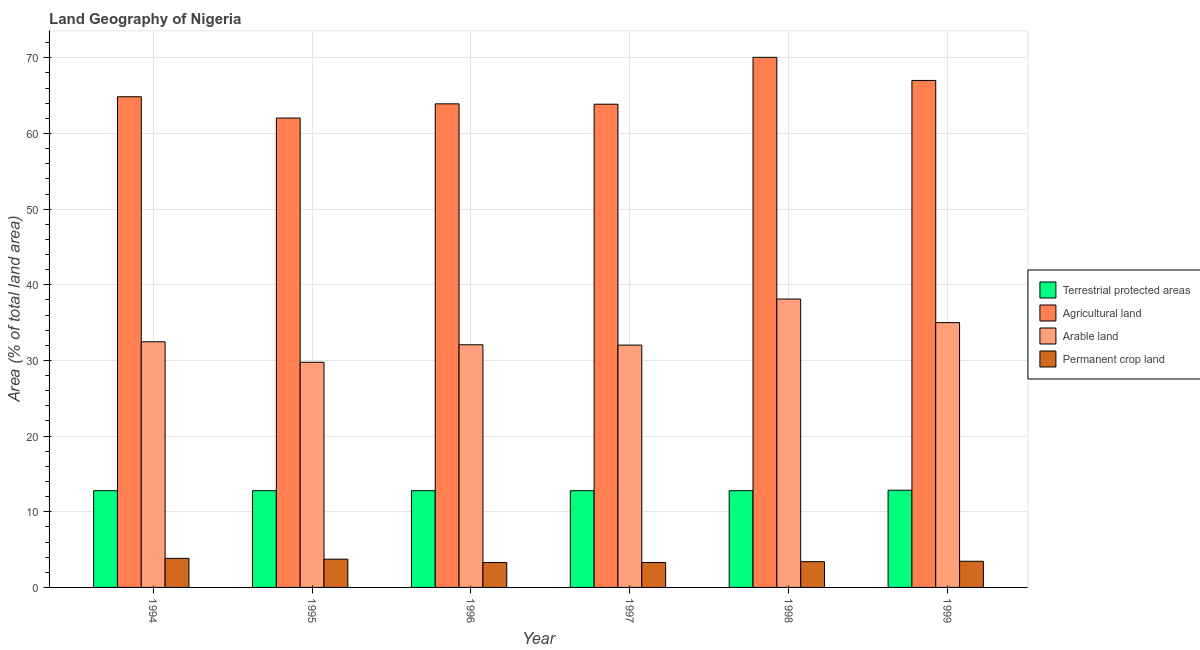How many different coloured bars are there?
Offer a very short reply. 4. Are the number of bars per tick equal to the number of legend labels?
Offer a terse response. Yes. How many bars are there on the 2nd tick from the left?
Ensure brevity in your answer.  4. What is the label of the 4th group of bars from the left?
Your answer should be compact. 1997. What is the percentage of area under arable land in 1995?
Your answer should be very brief. 29.76. Across all years, what is the maximum percentage of area under permanent crop land?
Keep it short and to the point. 3.84. Across all years, what is the minimum percentage of area under arable land?
Keep it short and to the point. 29.76. In which year was the percentage of land under terrestrial protection maximum?
Provide a short and direct response. 1999. What is the total percentage of land under terrestrial protection in the graph?
Give a very brief answer. 76.76. What is the difference between the percentage of area under permanent crop land in 1994 and that in 1996?
Your response must be concise. 0.55. What is the difference between the percentage of area under arable land in 1994 and the percentage of area under agricultural land in 1999?
Your answer should be very brief. -2.54. What is the average percentage of area under arable land per year?
Your response must be concise. 33.24. In how many years, is the percentage of area under permanent crop land greater than 62 %?
Offer a very short reply. 0. What is the ratio of the percentage of land under terrestrial protection in 1995 to that in 1998?
Your response must be concise. 1. Is the percentage of land under terrestrial protection in 1995 less than that in 1999?
Provide a short and direct response. Yes. Is the difference between the percentage of land under terrestrial protection in 1995 and 1997 greater than the difference between the percentage of area under agricultural land in 1995 and 1997?
Offer a terse response. No. What is the difference between the highest and the second highest percentage of area under agricultural land?
Make the answer very short. 3.06. What is the difference between the highest and the lowest percentage of area under permanent crop land?
Give a very brief answer. 0.55. Is the sum of the percentage of area under permanent crop land in 1998 and 1999 greater than the maximum percentage of land under terrestrial protection across all years?
Give a very brief answer. Yes. What does the 2nd bar from the left in 1997 represents?
Offer a terse response. Agricultural land. What does the 2nd bar from the right in 1997 represents?
Give a very brief answer. Arable land. Is it the case that in every year, the sum of the percentage of land under terrestrial protection and percentage of area under agricultural land is greater than the percentage of area under arable land?
Your answer should be compact. Yes. What is the difference between two consecutive major ticks on the Y-axis?
Provide a short and direct response. 10. Does the graph contain grids?
Keep it short and to the point. Yes. How many legend labels are there?
Offer a terse response. 4. How are the legend labels stacked?
Make the answer very short. Vertical. What is the title of the graph?
Your answer should be compact. Land Geography of Nigeria. What is the label or title of the X-axis?
Give a very brief answer. Year. What is the label or title of the Y-axis?
Your answer should be very brief. Area (% of total land area). What is the Area (% of total land area) in Terrestrial protected areas in 1994?
Make the answer very short. 12.78. What is the Area (% of total land area) in Agricultural land in 1994?
Offer a terse response. 64.86. What is the Area (% of total land area) of Arable land in 1994?
Provide a succinct answer. 32.47. What is the Area (% of total land area) of Permanent crop land in 1994?
Offer a terse response. 3.84. What is the Area (% of total land area) in Terrestrial protected areas in 1995?
Make the answer very short. 12.78. What is the Area (% of total land area) of Agricultural land in 1995?
Give a very brief answer. 62.04. What is the Area (% of total land area) in Arable land in 1995?
Make the answer very short. 29.76. What is the Area (% of total land area) of Permanent crop land in 1995?
Your response must be concise. 3.73. What is the Area (% of total land area) of Terrestrial protected areas in 1996?
Provide a succinct answer. 12.78. What is the Area (% of total land area) in Agricultural land in 1996?
Make the answer very short. 63.92. What is the Area (% of total land area) of Arable land in 1996?
Your answer should be compact. 32.07. What is the Area (% of total land area) in Permanent crop land in 1996?
Make the answer very short. 3.29. What is the Area (% of total land area) in Terrestrial protected areas in 1997?
Offer a terse response. 12.78. What is the Area (% of total land area) in Agricultural land in 1997?
Ensure brevity in your answer.  63.87. What is the Area (% of total land area) of Arable land in 1997?
Your response must be concise. 32.03. What is the Area (% of total land area) in Permanent crop land in 1997?
Make the answer very short. 3.29. What is the Area (% of total land area) of Terrestrial protected areas in 1998?
Your answer should be very brief. 12.78. What is the Area (% of total land area) of Agricultural land in 1998?
Your answer should be very brief. 70.07. What is the Area (% of total land area) of Arable land in 1998?
Provide a short and direct response. 38.12. What is the Area (% of total land area) of Permanent crop land in 1998?
Offer a terse response. 3.4. What is the Area (% of total land area) of Terrestrial protected areas in 1999?
Ensure brevity in your answer.  12.84. What is the Area (% of total land area) of Agricultural land in 1999?
Offer a terse response. 67.01. What is the Area (% of total land area) in Arable land in 1999?
Make the answer very short. 35. What is the Area (% of total land area) of Permanent crop land in 1999?
Keep it short and to the point. 3.46. Across all years, what is the maximum Area (% of total land area) of Terrestrial protected areas?
Give a very brief answer. 12.84. Across all years, what is the maximum Area (% of total land area) in Agricultural land?
Provide a succinct answer. 70.07. Across all years, what is the maximum Area (% of total land area) in Arable land?
Offer a terse response. 38.12. Across all years, what is the maximum Area (% of total land area) in Permanent crop land?
Make the answer very short. 3.84. Across all years, what is the minimum Area (% of total land area) of Terrestrial protected areas?
Give a very brief answer. 12.78. Across all years, what is the minimum Area (% of total land area) in Agricultural land?
Provide a short and direct response. 62.04. Across all years, what is the minimum Area (% of total land area) in Arable land?
Your response must be concise. 29.76. Across all years, what is the minimum Area (% of total land area) in Permanent crop land?
Offer a terse response. 3.29. What is the total Area (% of total land area) of Terrestrial protected areas in the graph?
Ensure brevity in your answer.  76.76. What is the total Area (% of total land area) in Agricultural land in the graph?
Provide a short and direct response. 391.76. What is the total Area (% of total land area) in Arable land in the graph?
Your answer should be very brief. 199.45. What is the total Area (% of total land area) of Permanent crop land in the graph?
Your answer should be very brief. 21.03. What is the difference between the Area (% of total land area) of Terrestrial protected areas in 1994 and that in 1995?
Give a very brief answer. 0. What is the difference between the Area (% of total land area) of Agricultural land in 1994 and that in 1995?
Your response must be concise. 2.82. What is the difference between the Area (% of total land area) in Arable land in 1994 and that in 1995?
Your answer should be compact. 2.71. What is the difference between the Area (% of total land area) in Permanent crop land in 1994 and that in 1995?
Provide a short and direct response. 0.11. What is the difference between the Area (% of total land area) of Terrestrial protected areas in 1994 and that in 1996?
Offer a terse response. 0. What is the difference between the Area (% of total land area) in Arable land in 1994 and that in 1996?
Ensure brevity in your answer.  0.39. What is the difference between the Area (% of total land area) in Permanent crop land in 1994 and that in 1996?
Give a very brief answer. 0.55. What is the difference between the Area (% of total land area) of Agricultural land in 1994 and that in 1997?
Make the answer very short. 0.99. What is the difference between the Area (% of total land area) in Arable land in 1994 and that in 1997?
Give a very brief answer. 0.44. What is the difference between the Area (% of total land area) of Permanent crop land in 1994 and that in 1997?
Ensure brevity in your answer.  0.55. What is the difference between the Area (% of total land area) of Terrestrial protected areas in 1994 and that in 1998?
Your answer should be very brief. 0. What is the difference between the Area (% of total land area) in Agricultural land in 1994 and that in 1998?
Ensure brevity in your answer.  -5.21. What is the difference between the Area (% of total land area) in Arable land in 1994 and that in 1998?
Your answer should be very brief. -5.65. What is the difference between the Area (% of total land area) of Permanent crop land in 1994 and that in 1998?
Keep it short and to the point. 0.44. What is the difference between the Area (% of total land area) of Terrestrial protected areas in 1994 and that in 1999?
Your answer should be very brief. -0.06. What is the difference between the Area (% of total land area) in Agricultural land in 1994 and that in 1999?
Make the answer very short. -2.15. What is the difference between the Area (% of total land area) in Arable land in 1994 and that in 1999?
Keep it short and to the point. -2.54. What is the difference between the Area (% of total land area) of Permanent crop land in 1994 and that in 1999?
Keep it short and to the point. 0.38. What is the difference between the Area (% of total land area) of Agricultural land in 1995 and that in 1996?
Your answer should be very brief. -1.87. What is the difference between the Area (% of total land area) in Arable land in 1995 and that in 1996?
Provide a succinct answer. -2.31. What is the difference between the Area (% of total land area) in Permanent crop land in 1995 and that in 1996?
Provide a short and direct response. 0.44. What is the difference between the Area (% of total land area) of Agricultural land in 1995 and that in 1997?
Your answer should be very brief. -1.83. What is the difference between the Area (% of total land area) of Arable land in 1995 and that in 1997?
Give a very brief answer. -2.27. What is the difference between the Area (% of total land area) of Permanent crop land in 1995 and that in 1997?
Offer a very short reply. 0.44. What is the difference between the Area (% of total land area) of Agricultural land in 1995 and that in 1998?
Offer a very short reply. -8.02. What is the difference between the Area (% of total land area) in Arable land in 1995 and that in 1998?
Make the answer very short. -8.35. What is the difference between the Area (% of total land area) in Permanent crop land in 1995 and that in 1998?
Give a very brief answer. 0.33. What is the difference between the Area (% of total land area) of Terrestrial protected areas in 1995 and that in 1999?
Provide a succinct answer. -0.06. What is the difference between the Area (% of total land area) of Agricultural land in 1995 and that in 1999?
Give a very brief answer. -4.97. What is the difference between the Area (% of total land area) in Arable land in 1995 and that in 1999?
Give a very brief answer. -5.24. What is the difference between the Area (% of total land area) of Permanent crop land in 1995 and that in 1999?
Offer a very short reply. 0.27. What is the difference between the Area (% of total land area) of Terrestrial protected areas in 1996 and that in 1997?
Offer a terse response. 0. What is the difference between the Area (% of total land area) in Agricultural land in 1996 and that in 1997?
Keep it short and to the point. 0.04. What is the difference between the Area (% of total land area) in Arable land in 1996 and that in 1997?
Make the answer very short. 0.04. What is the difference between the Area (% of total land area) of Terrestrial protected areas in 1996 and that in 1998?
Give a very brief answer. 0. What is the difference between the Area (% of total land area) of Agricultural land in 1996 and that in 1998?
Your response must be concise. -6.15. What is the difference between the Area (% of total land area) in Arable land in 1996 and that in 1998?
Keep it short and to the point. -6.04. What is the difference between the Area (% of total land area) of Permanent crop land in 1996 and that in 1998?
Provide a succinct answer. -0.11. What is the difference between the Area (% of total land area) of Terrestrial protected areas in 1996 and that in 1999?
Give a very brief answer. -0.06. What is the difference between the Area (% of total land area) in Agricultural land in 1996 and that in 1999?
Make the answer very short. -3.09. What is the difference between the Area (% of total land area) of Arable land in 1996 and that in 1999?
Give a very brief answer. -2.93. What is the difference between the Area (% of total land area) of Permanent crop land in 1996 and that in 1999?
Your response must be concise. -0.16. What is the difference between the Area (% of total land area) of Agricultural land in 1997 and that in 1998?
Offer a very short reply. -6.19. What is the difference between the Area (% of total land area) of Arable land in 1997 and that in 1998?
Offer a terse response. -6.08. What is the difference between the Area (% of total land area) in Permanent crop land in 1997 and that in 1998?
Make the answer very short. -0.11. What is the difference between the Area (% of total land area) in Terrestrial protected areas in 1997 and that in 1999?
Keep it short and to the point. -0.06. What is the difference between the Area (% of total land area) of Agricultural land in 1997 and that in 1999?
Keep it short and to the point. -3.14. What is the difference between the Area (% of total land area) in Arable land in 1997 and that in 1999?
Your answer should be compact. -2.97. What is the difference between the Area (% of total land area) of Permanent crop land in 1997 and that in 1999?
Make the answer very short. -0.16. What is the difference between the Area (% of total land area) in Terrestrial protected areas in 1998 and that in 1999?
Provide a short and direct response. -0.06. What is the difference between the Area (% of total land area) of Agricultural land in 1998 and that in 1999?
Your answer should be very brief. 3.06. What is the difference between the Area (% of total land area) in Arable land in 1998 and that in 1999?
Provide a succinct answer. 3.11. What is the difference between the Area (% of total land area) of Permanent crop land in 1998 and that in 1999?
Your response must be concise. -0.05. What is the difference between the Area (% of total land area) in Terrestrial protected areas in 1994 and the Area (% of total land area) in Agricultural land in 1995?
Your answer should be compact. -49.26. What is the difference between the Area (% of total land area) in Terrestrial protected areas in 1994 and the Area (% of total land area) in Arable land in 1995?
Your answer should be very brief. -16.98. What is the difference between the Area (% of total land area) of Terrestrial protected areas in 1994 and the Area (% of total land area) of Permanent crop land in 1995?
Keep it short and to the point. 9.05. What is the difference between the Area (% of total land area) in Agricultural land in 1994 and the Area (% of total land area) in Arable land in 1995?
Provide a succinct answer. 35.1. What is the difference between the Area (% of total land area) of Agricultural land in 1994 and the Area (% of total land area) of Permanent crop land in 1995?
Offer a terse response. 61.12. What is the difference between the Area (% of total land area) in Arable land in 1994 and the Area (% of total land area) in Permanent crop land in 1995?
Provide a short and direct response. 28.73. What is the difference between the Area (% of total land area) in Terrestrial protected areas in 1994 and the Area (% of total land area) in Agricultural land in 1996?
Give a very brief answer. -51.13. What is the difference between the Area (% of total land area) in Terrestrial protected areas in 1994 and the Area (% of total land area) in Arable land in 1996?
Give a very brief answer. -19.29. What is the difference between the Area (% of total land area) in Terrestrial protected areas in 1994 and the Area (% of total land area) in Permanent crop land in 1996?
Offer a terse response. 9.49. What is the difference between the Area (% of total land area) of Agricultural land in 1994 and the Area (% of total land area) of Arable land in 1996?
Offer a very short reply. 32.78. What is the difference between the Area (% of total land area) in Agricultural land in 1994 and the Area (% of total land area) in Permanent crop land in 1996?
Offer a very short reply. 61.56. What is the difference between the Area (% of total land area) of Arable land in 1994 and the Area (% of total land area) of Permanent crop land in 1996?
Offer a terse response. 29.17. What is the difference between the Area (% of total land area) of Terrestrial protected areas in 1994 and the Area (% of total land area) of Agricultural land in 1997?
Provide a succinct answer. -51.09. What is the difference between the Area (% of total land area) in Terrestrial protected areas in 1994 and the Area (% of total land area) in Arable land in 1997?
Offer a very short reply. -19.25. What is the difference between the Area (% of total land area) of Terrestrial protected areas in 1994 and the Area (% of total land area) of Permanent crop land in 1997?
Your answer should be very brief. 9.49. What is the difference between the Area (% of total land area) of Agricultural land in 1994 and the Area (% of total land area) of Arable land in 1997?
Keep it short and to the point. 32.83. What is the difference between the Area (% of total land area) in Agricultural land in 1994 and the Area (% of total land area) in Permanent crop land in 1997?
Give a very brief answer. 61.56. What is the difference between the Area (% of total land area) of Arable land in 1994 and the Area (% of total land area) of Permanent crop land in 1997?
Provide a succinct answer. 29.17. What is the difference between the Area (% of total land area) of Terrestrial protected areas in 1994 and the Area (% of total land area) of Agricultural land in 1998?
Offer a very short reply. -57.28. What is the difference between the Area (% of total land area) in Terrestrial protected areas in 1994 and the Area (% of total land area) in Arable land in 1998?
Keep it short and to the point. -25.33. What is the difference between the Area (% of total land area) of Terrestrial protected areas in 1994 and the Area (% of total land area) of Permanent crop land in 1998?
Make the answer very short. 9.38. What is the difference between the Area (% of total land area) in Agricultural land in 1994 and the Area (% of total land area) in Arable land in 1998?
Ensure brevity in your answer.  26.74. What is the difference between the Area (% of total land area) in Agricultural land in 1994 and the Area (% of total land area) in Permanent crop land in 1998?
Your answer should be very brief. 61.45. What is the difference between the Area (% of total land area) in Arable land in 1994 and the Area (% of total land area) in Permanent crop land in 1998?
Provide a succinct answer. 29.06. What is the difference between the Area (% of total land area) of Terrestrial protected areas in 1994 and the Area (% of total land area) of Agricultural land in 1999?
Offer a very short reply. -54.23. What is the difference between the Area (% of total land area) in Terrestrial protected areas in 1994 and the Area (% of total land area) in Arable land in 1999?
Provide a short and direct response. -22.22. What is the difference between the Area (% of total land area) in Terrestrial protected areas in 1994 and the Area (% of total land area) in Permanent crop land in 1999?
Offer a terse response. 9.32. What is the difference between the Area (% of total land area) of Agricultural land in 1994 and the Area (% of total land area) of Arable land in 1999?
Offer a terse response. 29.85. What is the difference between the Area (% of total land area) of Agricultural land in 1994 and the Area (% of total land area) of Permanent crop land in 1999?
Offer a terse response. 61.4. What is the difference between the Area (% of total land area) in Arable land in 1994 and the Area (% of total land area) in Permanent crop land in 1999?
Provide a short and direct response. 29.01. What is the difference between the Area (% of total land area) of Terrestrial protected areas in 1995 and the Area (% of total land area) of Agricultural land in 1996?
Make the answer very short. -51.13. What is the difference between the Area (% of total land area) of Terrestrial protected areas in 1995 and the Area (% of total land area) of Arable land in 1996?
Your answer should be compact. -19.29. What is the difference between the Area (% of total land area) in Terrestrial protected areas in 1995 and the Area (% of total land area) in Permanent crop land in 1996?
Provide a short and direct response. 9.49. What is the difference between the Area (% of total land area) of Agricultural land in 1995 and the Area (% of total land area) of Arable land in 1996?
Give a very brief answer. 29.97. What is the difference between the Area (% of total land area) in Agricultural land in 1995 and the Area (% of total land area) in Permanent crop land in 1996?
Offer a very short reply. 58.75. What is the difference between the Area (% of total land area) in Arable land in 1995 and the Area (% of total land area) in Permanent crop land in 1996?
Offer a very short reply. 26.47. What is the difference between the Area (% of total land area) of Terrestrial protected areas in 1995 and the Area (% of total land area) of Agricultural land in 1997?
Your response must be concise. -51.09. What is the difference between the Area (% of total land area) of Terrestrial protected areas in 1995 and the Area (% of total land area) of Arable land in 1997?
Offer a very short reply. -19.25. What is the difference between the Area (% of total land area) in Terrestrial protected areas in 1995 and the Area (% of total land area) in Permanent crop land in 1997?
Offer a very short reply. 9.49. What is the difference between the Area (% of total land area) in Agricultural land in 1995 and the Area (% of total land area) in Arable land in 1997?
Give a very brief answer. 30.01. What is the difference between the Area (% of total land area) of Agricultural land in 1995 and the Area (% of total land area) of Permanent crop land in 1997?
Your answer should be very brief. 58.75. What is the difference between the Area (% of total land area) in Arable land in 1995 and the Area (% of total land area) in Permanent crop land in 1997?
Give a very brief answer. 26.47. What is the difference between the Area (% of total land area) in Terrestrial protected areas in 1995 and the Area (% of total land area) in Agricultural land in 1998?
Give a very brief answer. -57.28. What is the difference between the Area (% of total land area) of Terrestrial protected areas in 1995 and the Area (% of total land area) of Arable land in 1998?
Give a very brief answer. -25.33. What is the difference between the Area (% of total land area) in Terrestrial protected areas in 1995 and the Area (% of total land area) in Permanent crop land in 1998?
Ensure brevity in your answer.  9.38. What is the difference between the Area (% of total land area) of Agricultural land in 1995 and the Area (% of total land area) of Arable land in 1998?
Give a very brief answer. 23.93. What is the difference between the Area (% of total land area) of Agricultural land in 1995 and the Area (% of total land area) of Permanent crop land in 1998?
Provide a short and direct response. 58.64. What is the difference between the Area (% of total land area) in Arable land in 1995 and the Area (% of total land area) in Permanent crop land in 1998?
Offer a terse response. 26.36. What is the difference between the Area (% of total land area) in Terrestrial protected areas in 1995 and the Area (% of total land area) in Agricultural land in 1999?
Ensure brevity in your answer.  -54.23. What is the difference between the Area (% of total land area) in Terrestrial protected areas in 1995 and the Area (% of total land area) in Arable land in 1999?
Offer a very short reply. -22.22. What is the difference between the Area (% of total land area) in Terrestrial protected areas in 1995 and the Area (% of total land area) in Permanent crop land in 1999?
Make the answer very short. 9.32. What is the difference between the Area (% of total land area) in Agricultural land in 1995 and the Area (% of total land area) in Arable land in 1999?
Your answer should be compact. 27.04. What is the difference between the Area (% of total land area) of Agricultural land in 1995 and the Area (% of total land area) of Permanent crop land in 1999?
Your answer should be compact. 58.58. What is the difference between the Area (% of total land area) of Arable land in 1995 and the Area (% of total land area) of Permanent crop land in 1999?
Your answer should be very brief. 26.3. What is the difference between the Area (% of total land area) in Terrestrial protected areas in 1996 and the Area (% of total land area) in Agricultural land in 1997?
Provide a short and direct response. -51.09. What is the difference between the Area (% of total land area) of Terrestrial protected areas in 1996 and the Area (% of total land area) of Arable land in 1997?
Your response must be concise. -19.25. What is the difference between the Area (% of total land area) in Terrestrial protected areas in 1996 and the Area (% of total land area) in Permanent crop land in 1997?
Provide a succinct answer. 9.49. What is the difference between the Area (% of total land area) in Agricultural land in 1996 and the Area (% of total land area) in Arable land in 1997?
Your response must be concise. 31.89. What is the difference between the Area (% of total land area) in Agricultural land in 1996 and the Area (% of total land area) in Permanent crop land in 1997?
Make the answer very short. 60.62. What is the difference between the Area (% of total land area) of Arable land in 1996 and the Area (% of total land area) of Permanent crop land in 1997?
Give a very brief answer. 28.78. What is the difference between the Area (% of total land area) of Terrestrial protected areas in 1996 and the Area (% of total land area) of Agricultural land in 1998?
Provide a short and direct response. -57.28. What is the difference between the Area (% of total land area) in Terrestrial protected areas in 1996 and the Area (% of total land area) in Arable land in 1998?
Keep it short and to the point. -25.33. What is the difference between the Area (% of total land area) in Terrestrial protected areas in 1996 and the Area (% of total land area) in Permanent crop land in 1998?
Ensure brevity in your answer.  9.38. What is the difference between the Area (% of total land area) of Agricultural land in 1996 and the Area (% of total land area) of Arable land in 1998?
Your answer should be very brief. 25.8. What is the difference between the Area (% of total land area) of Agricultural land in 1996 and the Area (% of total land area) of Permanent crop land in 1998?
Keep it short and to the point. 60.51. What is the difference between the Area (% of total land area) of Arable land in 1996 and the Area (% of total land area) of Permanent crop land in 1998?
Your answer should be compact. 28.67. What is the difference between the Area (% of total land area) in Terrestrial protected areas in 1996 and the Area (% of total land area) in Agricultural land in 1999?
Your answer should be compact. -54.23. What is the difference between the Area (% of total land area) in Terrestrial protected areas in 1996 and the Area (% of total land area) in Arable land in 1999?
Make the answer very short. -22.22. What is the difference between the Area (% of total land area) in Terrestrial protected areas in 1996 and the Area (% of total land area) in Permanent crop land in 1999?
Provide a succinct answer. 9.32. What is the difference between the Area (% of total land area) in Agricultural land in 1996 and the Area (% of total land area) in Arable land in 1999?
Keep it short and to the point. 28.91. What is the difference between the Area (% of total land area) of Agricultural land in 1996 and the Area (% of total land area) of Permanent crop land in 1999?
Offer a very short reply. 60.46. What is the difference between the Area (% of total land area) in Arable land in 1996 and the Area (% of total land area) in Permanent crop land in 1999?
Offer a very short reply. 28.62. What is the difference between the Area (% of total land area) of Terrestrial protected areas in 1997 and the Area (% of total land area) of Agricultural land in 1998?
Ensure brevity in your answer.  -57.28. What is the difference between the Area (% of total land area) of Terrestrial protected areas in 1997 and the Area (% of total land area) of Arable land in 1998?
Offer a terse response. -25.33. What is the difference between the Area (% of total land area) of Terrestrial protected areas in 1997 and the Area (% of total land area) of Permanent crop land in 1998?
Offer a terse response. 9.38. What is the difference between the Area (% of total land area) of Agricultural land in 1997 and the Area (% of total land area) of Arable land in 1998?
Give a very brief answer. 25.76. What is the difference between the Area (% of total land area) of Agricultural land in 1997 and the Area (% of total land area) of Permanent crop land in 1998?
Ensure brevity in your answer.  60.47. What is the difference between the Area (% of total land area) of Arable land in 1997 and the Area (% of total land area) of Permanent crop land in 1998?
Give a very brief answer. 28.63. What is the difference between the Area (% of total land area) in Terrestrial protected areas in 1997 and the Area (% of total land area) in Agricultural land in 1999?
Your response must be concise. -54.23. What is the difference between the Area (% of total land area) in Terrestrial protected areas in 1997 and the Area (% of total land area) in Arable land in 1999?
Your answer should be compact. -22.22. What is the difference between the Area (% of total land area) of Terrestrial protected areas in 1997 and the Area (% of total land area) of Permanent crop land in 1999?
Offer a terse response. 9.32. What is the difference between the Area (% of total land area) of Agricultural land in 1997 and the Area (% of total land area) of Arable land in 1999?
Provide a short and direct response. 28.87. What is the difference between the Area (% of total land area) in Agricultural land in 1997 and the Area (% of total land area) in Permanent crop land in 1999?
Provide a succinct answer. 60.41. What is the difference between the Area (% of total land area) in Arable land in 1997 and the Area (% of total land area) in Permanent crop land in 1999?
Offer a terse response. 28.57. What is the difference between the Area (% of total land area) of Terrestrial protected areas in 1998 and the Area (% of total land area) of Agricultural land in 1999?
Your response must be concise. -54.23. What is the difference between the Area (% of total land area) of Terrestrial protected areas in 1998 and the Area (% of total land area) of Arable land in 1999?
Offer a very short reply. -22.22. What is the difference between the Area (% of total land area) in Terrestrial protected areas in 1998 and the Area (% of total land area) in Permanent crop land in 1999?
Offer a terse response. 9.32. What is the difference between the Area (% of total land area) of Agricultural land in 1998 and the Area (% of total land area) of Arable land in 1999?
Provide a succinct answer. 35.06. What is the difference between the Area (% of total land area) of Agricultural land in 1998 and the Area (% of total land area) of Permanent crop land in 1999?
Offer a very short reply. 66.61. What is the difference between the Area (% of total land area) of Arable land in 1998 and the Area (% of total land area) of Permanent crop land in 1999?
Keep it short and to the point. 34.66. What is the average Area (% of total land area) in Terrestrial protected areas per year?
Give a very brief answer. 12.79. What is the average Area (% of total land area) in Agricultural land per year?
Your answer should be compact. 65.29. What is the average Area (% of total land area) of Arable land per year?
Offer a terse response. 33.24. What is the average Area (% of total land area) of Permanent crop land per year?
Provide a succinct answer. 3.5. In the year 1994, what is the difference between the Area (% of total land area) of Terrestrial protected areas and Area (% of total land area) of Agricultural land?
Provide a succinct answer. -52.07. In the year 1994, what is the difference between the Area (% of total land area) in Terrestrial protected areas and Area (% of total land area) in Arable land?
Provide a short and direct response. -19.68. In the year 1994, what is the difference between the Area (% of total land area) in Terrestrial protected areas and Area (% of total land area) in Permanent crop land?
Ensure brevity in your answer.  8.94. In the year 1994, what is the difference between the Area (% of total land area) of Agricultural land and Area (% of total land area) of Arable land?
Give a very brief answer. 32.39. In the year 1994, what is the difference between the Area (% of total land area) in Agricultural land and Area (% of total land area) in Permanent crop land?
Offer a very short reply. 61.01. In the year 1994, what is the difference between the Area (% of total land area) of Arable land and Area (% of total land area) of Permanent crop land?
Offer a very short reply. 28.62. In the year 1995, what is the difference between the Area (% of total land area) of Terrestrial protected areas and Area (% of total land area) of Agricultural land?
Your answer should be compact. -49.26. In the year 1995, what is the difference between the Area (% of total land area) of Terrestrial protected areas and Area (% of total land area) of Arable land?
Your response must be concise. -16.98. In the year 1995, what is the difference between the Area (% of total land area) of Terrestrial protected areas and Area (% of total land area) of Permanent crop land?
Ensure brevity in your answer.  9.05. In the year 1995, what is the difference between the Area (% of total land area) of Agricultural land and Area (% of total land area) of Arable land?
Make the answer very short. 32.28. In the year 1995, what is the difference between the Area (% of total land area) of Agricultural land and Area (% of total land area) of Permanent crop land?
Your answer should be very brief. 58.31. In the year 1995, what is the difference between the Area (% of total land area) of Arable land and Area (% of total land area) of Permanent crop land?
Keep it short and to the point. 26.03. In the year 1996, what is the difference between the Area (% of total land area) in Terrestrial protected areas and Area (% of total land area) in Agricultural land?
Your answer should be very brief. -51.13. In the year 1996, what is the difference between the Area (% of total land area) of Terrestrial protected areas and Area (% of total land area) of Arable land?
Provide a short and direct response. -19.29. In the year 1996, what is the difference between the Area (% of total land area) of Terrestrial protected areas and Area (% of total land area) of Permanent crop land?
Provide a succinct answer. 9.49. In the year 1996, what is the difference between the Area (% of total land area) in Agricultural land and Area (% of total land area) in Arable land?
Offer a terse response. 31.84. In the year 1996, what is the difference between the Area (% of total land area) of Agricultural land and Area (% of total land area) of Permanent crop land?
Your response must be concise. 60.62. In the year 1996, what is the difference between the Area (% of total land area) in Arable land and Area (% of total land area) in Permanent crop land?
Provide a short and direct response. 28.78. In the year 1997, what is the difference between the Area (% of total land area) in Terrestrial protected areas and Area (% of total land area) in Agricultural land?
Your answer should be very brief. -51.09. In the year 1997, what is the difference between the Area (% of total land area) of Terrestrial protected areas and Area (% of total land area) of Arable land?
Provide a succinct answer. -19.25. In the year 1997, what is the difference between the Area (% of total land area) of Terrestrial protected areas and Area (% of total land area) of Permanent crop land?
Your answer should be compact. 9.49. In the year 1997, what is the difference between the Area (% of total land area) in Agricultural land and Area (% of total land area) in Arable land?
Provide a succinct answer. 31.84. In the year 1997, what is the difference between the Area (% of total land area) of Agricultural land and Area (% of total land area) of Permanent crop land?
Keep it short and to the point. 60.58. In the year 1997, what is the difference between the Area (% of total land area) of Arable land and Area (% of total land area) of Permanent crop land?
Keep it short and to the point. 28.74. In the year 1998, what is the difference between the Area (% of total land area) of Terrestrial protected areas and Area (% of total land area) of Agricultural land?
Your answer should be compact. -57.28. In the year 1998, what is the difference between the Area (% of total land area) of Terrestrial protected areas and Area (% of total land area) of Arable land?
Offer a terse response. -25.33. In the year 1998, what is the difference between the Area (% of total land area) in Terrestrial protected areas and Area (% of total land area) in Permanent crop land?
Make the answer very short. 9.38. In the year 1998, what is the difference between the Area (% of total land area) in Agricultural land and Area (% of total land area) in Arable land?
Keep it short and to the point. 31.95. In the year 1998, what is the difference between the Area (% of total land area) of Agricultural land and Area (% of total land area) of Permanent crop land?
Ensure brevity in your answer.  66.66. In the year 1998, what is the difference between the Area (% of total land area) of Arable land and Area (% of total land area) of Permanent crop land?
Make the answer very short. 34.71. In the year 1999, what is the difference between the Area (% of total land area) of Terrestrial protected areas and Area (% of total land area) of Agricultural land?
Provide a short and direct response. -54.16. In the year 1999, what is the difference between the Area (% of total land area) in Terrestrial protected areas and Area (% of total land area) in Arable land?
Make the answer very short. -22.16. In the year 1999, what is the difference between the Area (% of total land area) in Terrestrial protected areas and Area (% of total land area) in Permanent crop land?
Give a very brief answer. 9.39. In the year 1999, what is the difference between the Area (% of total land area) in Agricultural land and Area (% of total land area) in Arable land?
Make the answer very short. 32.01. In the year 1999, what is the difference between the Area (% of total land area) of Agricultural land and Area (% of total land area) of Permanent crop land?
Offer a very short reply. 63.55. In the year 1999, what is the difference between the Area (% of total land area) in Arable land and Area (% of total land area) in Permanent crop land?
Your response must be concise. 31.55. What is the ratio of the Area (% of total land area) in Terrestrial protected areas in 1994 to that in 1995?
Offer a terse response. 1. What is the ratio of the Area (% of total land area) in Agricultural land in 1994 to that in 1995?
Offer a very short reply. 1.05. What is the ratio of the Area (% of total land area) in Arable land in 1994 to that in 1995?
Offer a terse response. 1.09. What is the ratio of the Area (% of total land area) of Permanent crop land in 1994 to that in 1995?
Provide a short and direct response. 1.03. What is the ratio of the Area (% of total land area) in Agricultural land in 1994 to that in 1996?
Your answer should be very brief. 1.01. What is the ratio of the Area (% of total land area) of Arable land in 1994 to that in 1996?
Provide a short and direct response. 1.01. What is the ratio of the Area (% of total land area) in Permanent crop land in 1994 to that in 1996?
Ensure brevity in your answer.  1.17. What is the ratio of the Area (% of total land area) of Agricultural land in 1994 to that in 1997?
Ensure brevity in your answer.  1.02. What is the ratio of the Area (% of total land area) in Arable land in 1994 to that in 1997?
Offer a terse response. 1.01. What is the ratio of the Area (% of total land area) in Permanent crop land in 1994 to that in 1997?
Ensure brevity in your answer.  1.17. What is the ratio of the Area (% of total land area) of Terrestrial protected areas in 1994 to that in 1998?
Make the answer very short. 1. What is the ratio of the Area (% of total land area) in Agricultural land in 1994 to that in 1998?
Your answer should be compact. 0.93. What is the ratio of the Area (% of total land area) of Arable land in 1994 to that in 1998?
Keep it short and to the point. 0.85. What is the ratio of the Area (% of total land area) in Permanent crop land in 1994 to that in 1998?
Ensure brevity in your answer.  1.13. What is the ratio of the Area (% of total land area) in Terrestrial protected areas in 1994 to that in 1999?
Keep it short and to the point. 1. What is the ratio of the Area (% of total land area) in Agricultural land in 1994 to that in 1999?
Offer a terse response. 0.97. What is the ratio of the Area (% of total land area) of Arable land in 1994 to that in 1999?
Offer a terse response. 0.93. What is the ratio of the Area (% of total land area) in Permanent crop land in 1994 to that in 1999?
Provide a succinct answer. 1.11. What is the ratio of the Area (% of total land area) in Agricultural land in 1995 to that in 1996?
Your answer should be very brief. 0.97. What is the ratio of the Area (% of total land area) in Arable land in 1995 to that in 1996?
Make the answer very short. 0.93. What is the ratio of the Area (% of total land area) of Permanent crop land in 1995 to that in 1996?
Keep it short and to the point. 1.13. What is the ratio of the Area (% of total land area) in Agricultural land in 1995 to that in 1997?
Your answer should be compact. 0.97. What is the ratio of the Area (% of total land area) of Arable land in 1995 to that in 1997?
Your answer should be very brief. 0.93. What is the ratio of the Area (% of total land area) of Permanent crop land in 1995 to that in 1997?
Ensure brevity in your answer.  1.13. What is the ratio of the Area (% of total land area) of Terrestrial protected areas in 1995 to that in 1998?
Offer a terse response. 1. What is the ratio of the Area (% of total land area) in Agricultural land in 1995 to that in 1998?
Your answer should be very brief. 0.89. What is the ratio of the Area (% of total land area) in Arable land in 1995 to that in 1998?
Provide a short and direct response. 0.78. What is the ratio of the Area (% of total land area) of Permanent crop land in 1995 to that in 1998?
Your response must be concise. 1.1. What is the ratio of the Area (% of total land area) in Terrestrial protected areas in 1995 to that in 1999?
Give a very brief answer. 1. What is the ratio of the Area (% of total land area) in Agricultural land in 1995 to that in 1999?
Ensure brevity in your answer.  0.93. What is the ratio of the Area (% of total land area) in Arable land in 1995 to that in 1999?
Give a very brief answer. 0.85. What is the ratio of the Area (% of total land area) in Permanent crop land in 1995 to that in 1999?
Your answer should be very brief. 1.08. What is the ratio of the Area (% of total land area) in Terrestrial protected areas in 1996 to that in 1997?
Provide a short and direct response. 1. What is the ratio of the Area (% of total land area) of Arable land in 1996 to that in 1997?
Your response must be concise. 1. What is the ratio of the Area (% of total land area) of Agricultural land in 1996 to that in 1998?
Make the answer very short. 0.91. What is the ratio of the Area (% of total land area) in Arable land in 1996 to that in 1998?
Keep it short and to the point. 0.84. What is the ratio of the Area (% of total land area) in Permanent crop land in 1996 to that in 1998?
Keep it short and to the point. 0.97. What is the ratio of the Area (% of total land area) in Agricultural land in 1996 to that in 1999?
Provide a succinct answer. 0.95. What is the ratio of the Area (% of total land area) in Arable land in 1996 to that in 1999?
Provide a succinct answer. 0.92. What is the ratio of the Area (% of total land area) in Agricultural land in 1997 to that in 1998?
Provide a succinct answer. 0.91. What is the ratio of the Area (% of total land area) in Arable land in 1997 to that in 1998?
Offer a very short reply. 0.84. What is the ratio of the Area (% of total land area) of Agricultural land in 1997 to that in 1999?
Make the answer very short. 0.95. What is the ratio of the Area (% of total land area) in Arable land in 1997 to that in 1999?
Provide a succinct answer. 0.92. What is the ratio of the Area (% of total land area) of Permanent crop land in 1997 to that in 1999?
Offer a terse response. 0.95. What is the ratio of the Area (% of total land area) of Agricultural land in 1998 to that in 1999?
Keep it short and to the point. 1.05. What is the ratio of the Area (% of total land area) of Arable land in 1998 to that in 1999?
Your answer should be very brief. 1.09. What is the ratio of the Area (% of total land area) in Permanent crop land in 1998 to that in 1999?
Offer a terse response. 0.98. What is the difference between the highest and the second highest Area (% of total land area) in Terrestrial protected areas?
Provide a short and direct response. 0.06. What is the difference between the highest and the second highest Area (% of total land area) in Agricultural land?
Ensure brevity in your answer.  3.06. What is the difference between the highest and the second highest Area (% of total land area) of Arable land?
Offer a terse response. 3.11. What is the difference between the highest and the second highest Area (% of total land area) in Permanent crop land?
Your answer should be very brief. 0.11. What is the difference between the highest and the lowest Area (% of total land area) in Terrestrial protected areas?
Keep it short and to the point. 0.06. What is the difference between the highest and the lowest Area (% of total land area) of Agricultural land?
Ensure brevity in your answer.  8.02. What is the difference between the highest and the lowest Area (% of total land area) of Arable land?
Make the answer very short. 8.35. What is the difference between the highest and the lowest Area (% of total land area) of Permanent crop land?
Offer a very short reply. 0.55. 